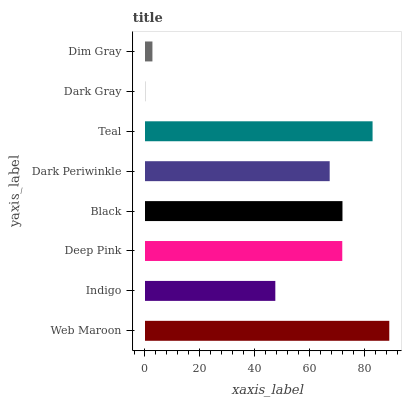Is Dark Gray the minimum?
Answer yes or no. Yes. Is Web Maroon the maximum?
Answer yes or no. Yes. Is Indigo the minimum?
Answer yes or no. No. Is Indigo the maximum?
Answer yes or no. No. Is Web Maroon greater than Indigo?
Answer yes or no. Yes. Is Indigo less than Web Maroon?
Answer yes or no. Yes. Is Indigo greater than Web Maroon?
Answer yes or no. No. Is Web Maroon less than Indigo?
Answer yes or no. No. Is Deep Pink the high median?
Answer yes or no. Yes. Is Dark Periwinkle the low median?
Answer yes or no. Yes. Is Dim Gray the high median?
Answer yes or no. No. Is Web Maroon the low median?
Answer yes or no. No. 